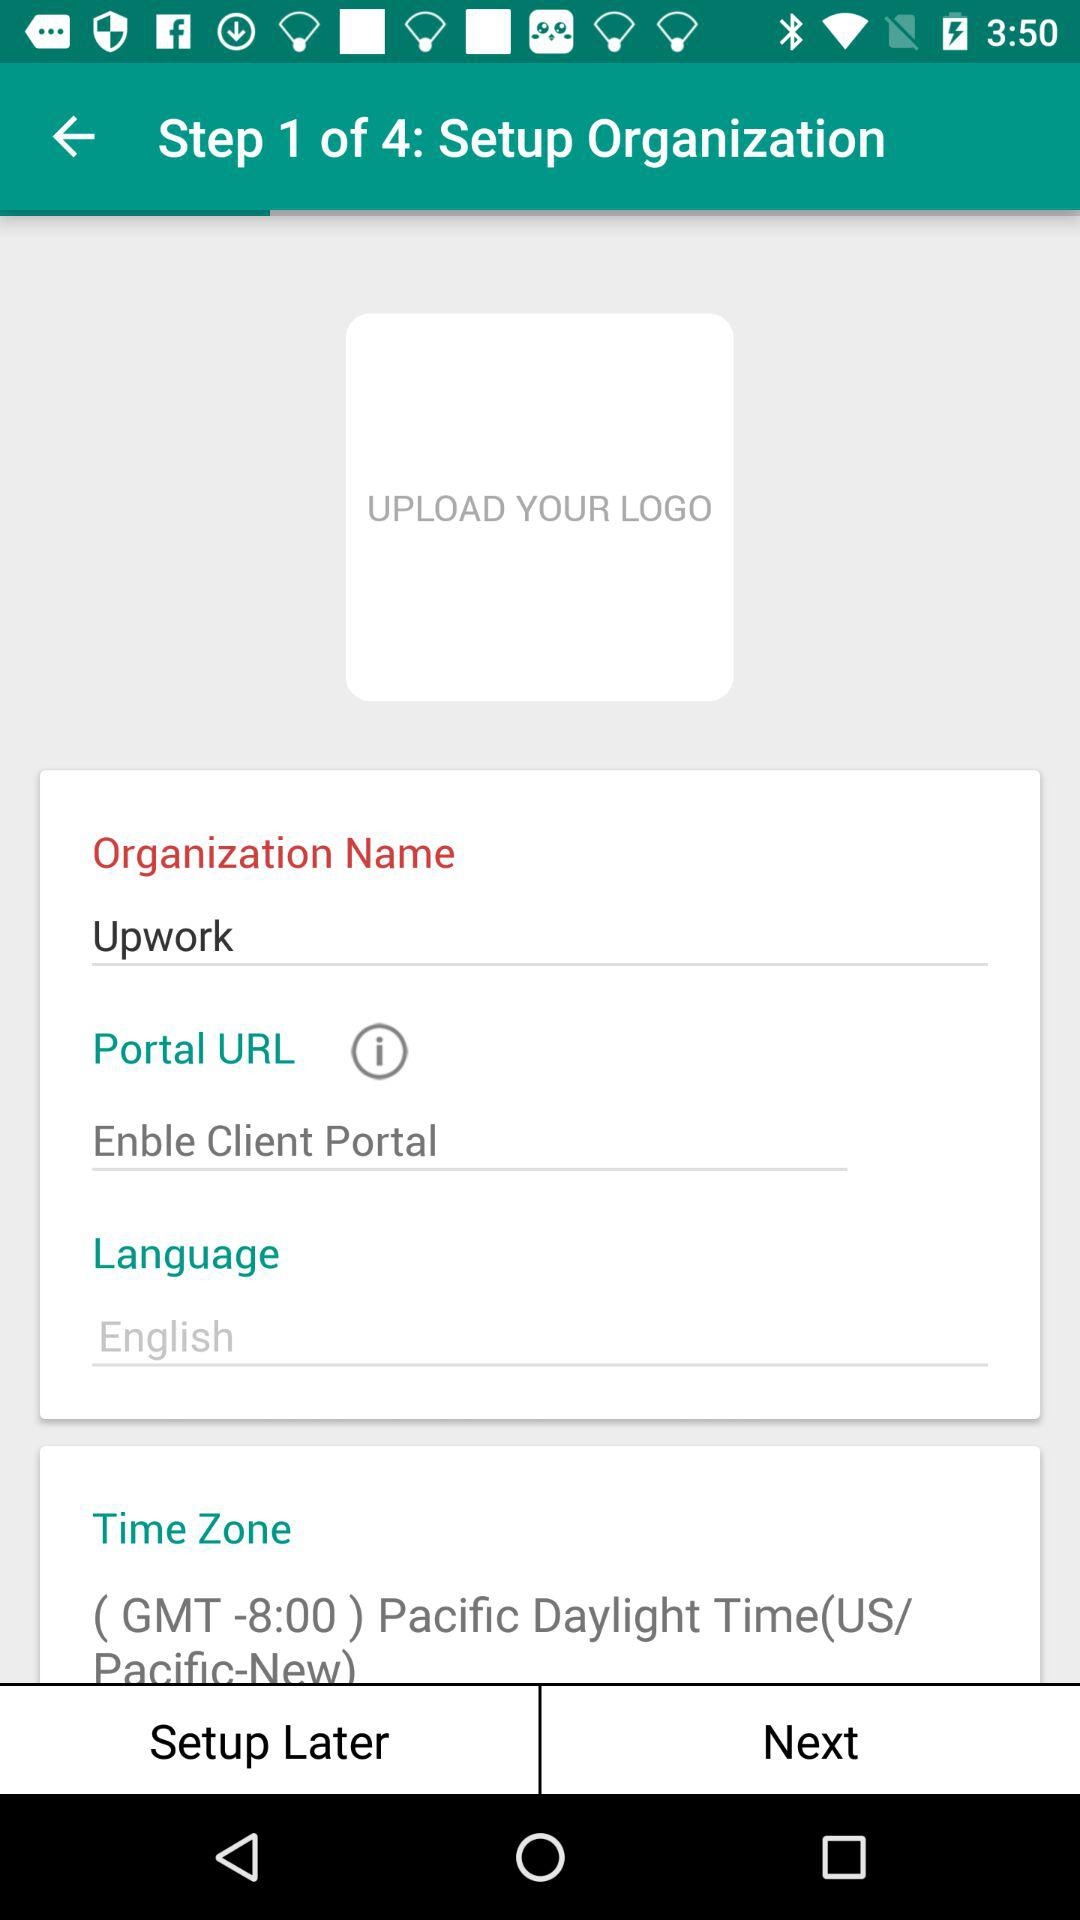How many items have a text input?
Answer the question using a single word or phrase. 3 